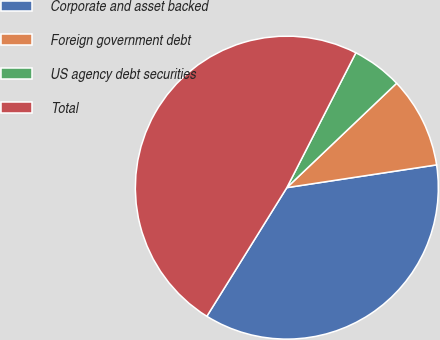Convert chart to OTSL. <chart><loc_0><loc_0><loc_500><loc_500><pie_chart><fcel>Corporate and asset backed<fcel>Foreign government debt<fcel>US agency debt securities<fcel>Total<nl><fcel>36.25%<fcel>9.7%<fcel>5.37%<fcel>48.67%<nl></chart> 